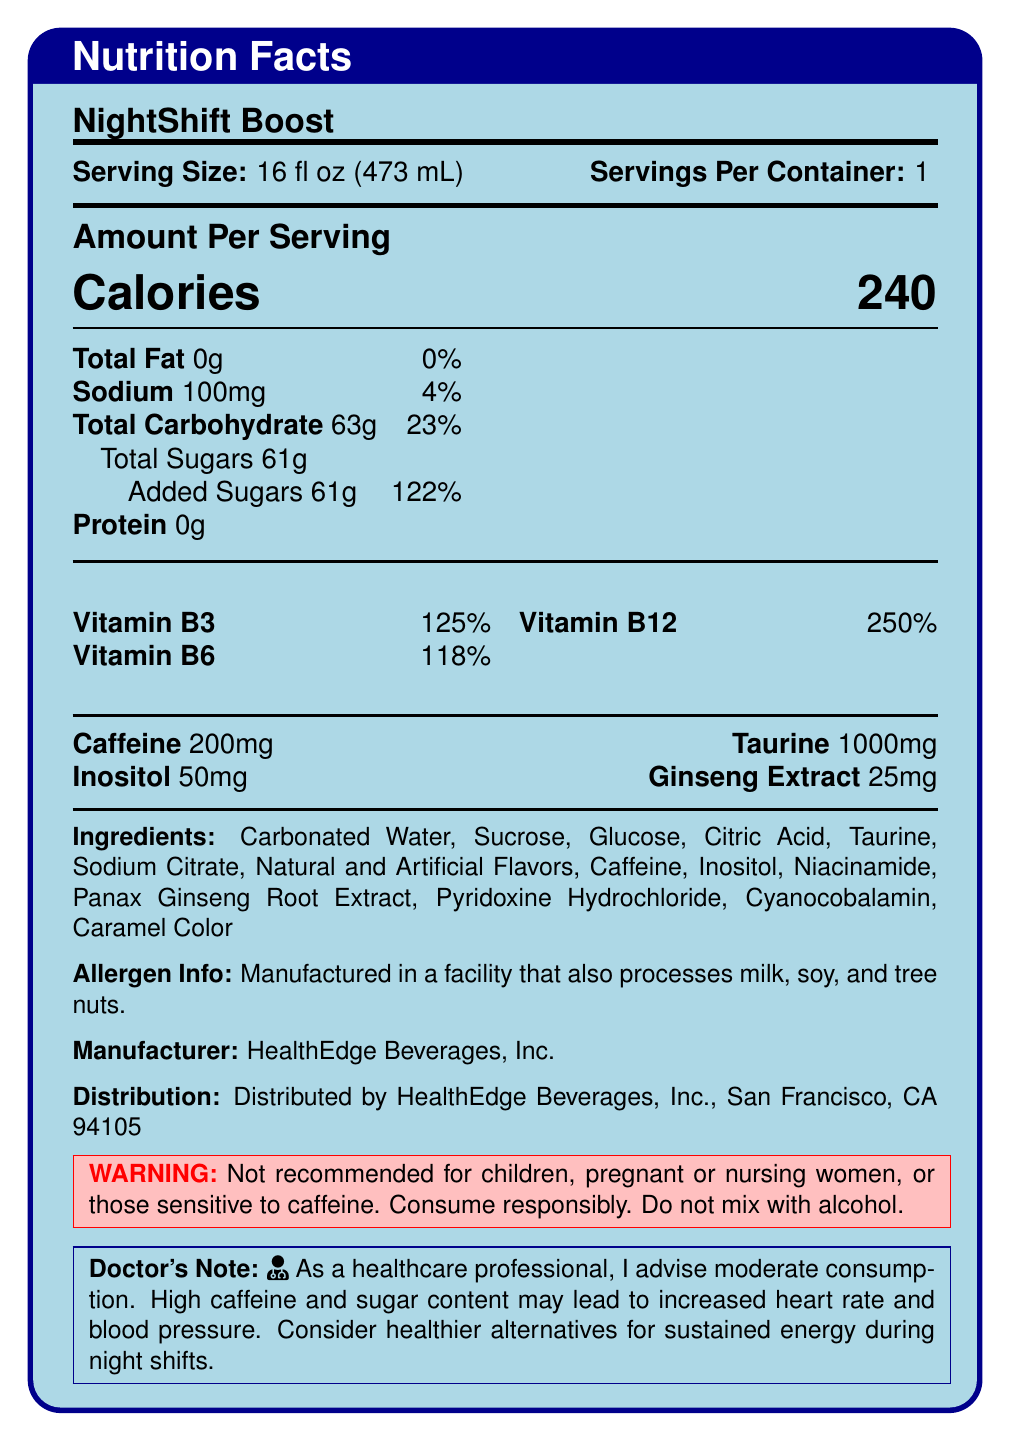what is the serving size of NightShift Boost? The serving size is clearly mentioned at the top of the document as "Serving Size: 16 fl oz (473 mL)".
Answer: 16 fl oz (473 mL) how many calories are there per serving? The amount of calories per serving is prominently displayed in large font as "Calories 240".
Answer: 240 calories what is the amount of total sugars in NightShift Boost? The total sugars amount is listed under the "Total Carbohydrate" section with "Total Sugars 61g".
Answer: 61g what is the content of caffeine per serving? The caffeine content is listed towards the bottom of the main section as "Caffeine 200mg".
Answer: 200mg what percentage of the daily value of Vitamin B12 does one serving provide? The daily value percentage for Vitamin B12 is indicated as "Vitamin B12 250%" under the vitamin section.
Answer: 250% which of the following is NOT an ingredient in NightShift Boost? A. Sucrose B. Citric Acid C. Ascorbic Acid The ingredient list does not mention Ascorbic Acid. Sucrose and Citric Acid are listed among the ingredients.
Answer: C what is the daily value percentage of sodium in one serving? A. 2% B. 4% C. 8% D. 12% The sodium amount is listed as "Sodium 100mg" with a daily value of "4%".
Answer: B are there any warnings mentioned for NightShift Boost? The document includes a warning stating, "Not recommended for children, pregnant or nursing women, or those sensitive to caffeine. Consume responsibly. Do not mix with alcohol."
Answer: Yes summarize the Nutrition Facts label for NightShift Boost. This summary captures the primary information provided in the Nutrition Facts label, the ingredients list, and the warnings and notes included in the document.
Answer: NightShift Boost is an energy drink with a serving size of 16 fl oz (473 mL). It contains 240 calories per serving, with 0g of fat, 100mg of sodium (4% DV), 63g of carbohydrates (23% DV), including 61g of total sugars, all of which are added sugars (122% DV). It has no protein, 200mg of caffeine, and essential vitamins like Vitamin B3 (125% DV), B6 (118% DV), and B12 (250% DV). Additional ingredients include taurine, inositol, and ginseng extract. Warnings indicate it's not recommended for certain groups and should not be mixed with alcohol. There's a doctor's note advising moderate consumption due to high caffeine and sugar content. what is the sodium content compared to the daily value percentage? The sodium content is specified as 100mg, with a daily value percentage of 4%.
Answer: 100mg how many grams of protein does NightShift Boost contain? The document clearly lists "Protein 0g" indicating there is no protein in one serving.
Answer: 0g what is the manufacturer of NightShift Boost? The manufacturer is mentioned towards the bottom of the document as "Manufacturer: HealthEdge Beverages, Inc."
Answer: HealthEdge Beverages, Inc. what is the purpose of taurine added in an energy drink? The document lists taurine as an ingredient but does not provide any information on its purpose or benefits.
Answer: Cannot be determined is NightShift Boost suitable for children? The document clearly states, "Not recommended for children" in the warning section.
Answer: No what are the main concerns mentioned in the doctor's note about NightShift Boost? The doctor's note advises moderate consumption and mentions concerns about the high caffeine and sugar content which may lead to increased heart rate and blood pressure.
Answer: High caffeine and sugar content 